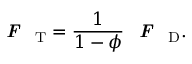<formula> <loc_0><loc_0><loc_500><loc_500>F _ { T } = \frac { 1 } { 1 - \phi } F _ { D } .</formula> 